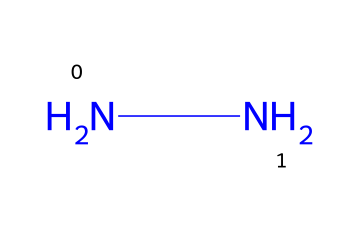What is the molecular formula of hydrazine? The SMILES representation "NN" indicates that there are two nitrogen atoms (N) and no other elements present in the structure. Therefore, the molecular formula is derived directly from the count of nitrogen atoms.
Answer: N2H4 How many nitrogen atoms are present in hydrazine? The SMILES "NN" denotes that there are two nitrogen atoms connected to each other, clearly indicating the number of nitrogen atoms.
Answer: 2 What type of bonds are between the nitrogen atoms in hydrazine? In the SMILES, "NN" suggests a single bond between the two nitrogen atoms, as there are no multiple bond indicators present (like '=' for double bonds). This establishes that it contains a single bond.
Answer: single bond Is hydrazine a solid, liquid, or gas at room temperature? Generally, hydrazine is known to be a liquid at room temperature, which can be determined from its physical properties commonly associated with small molecular weight compounds of nitrogen.
Answer: liquid What is a common application of hydrazine? Hydrazine is frequently used as a propulsion fuel in rockets, a fact that is associated with its properties as a reducing agent and energy-dense compound.
Answer: rocket fuel Why is hydrazine considered a good rocket fuel? Hydrazine has a high specific impulse (efficiency) due to its ability to produce a significant amount of thrust when decomposed, along with its ease of storage and handling compared to other fuels. The efficiency is due to the exothermic reactions it can undergo.
Answer: high specific impulse 